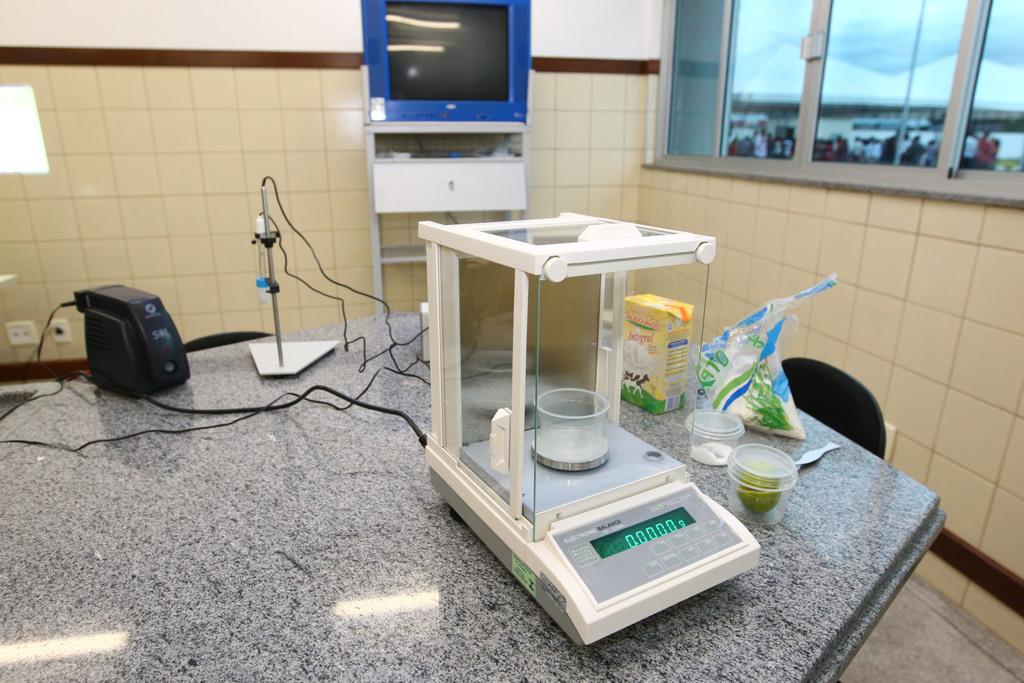What is the weight displayed on the scale?
Your answer should be compact. 0. 